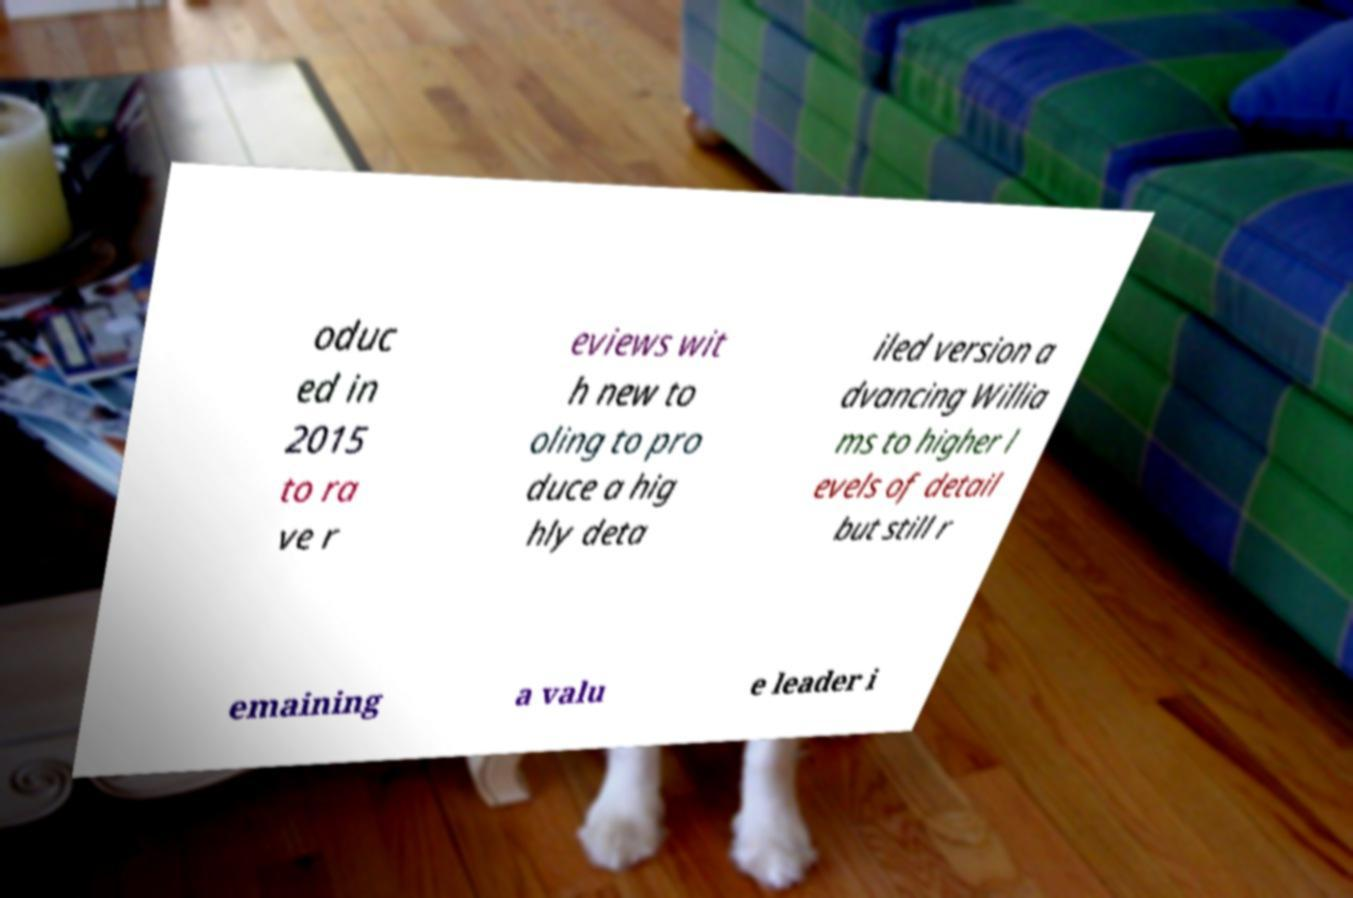Please read and relay the text visible in this image. What does it say? oduc ed in 2015 to ra ve r eviews wit h new to oling to pro duce a hig hly deta iled version a dvancing Willia ms to higher l evels of detail but still r emaining a valu e leader i 